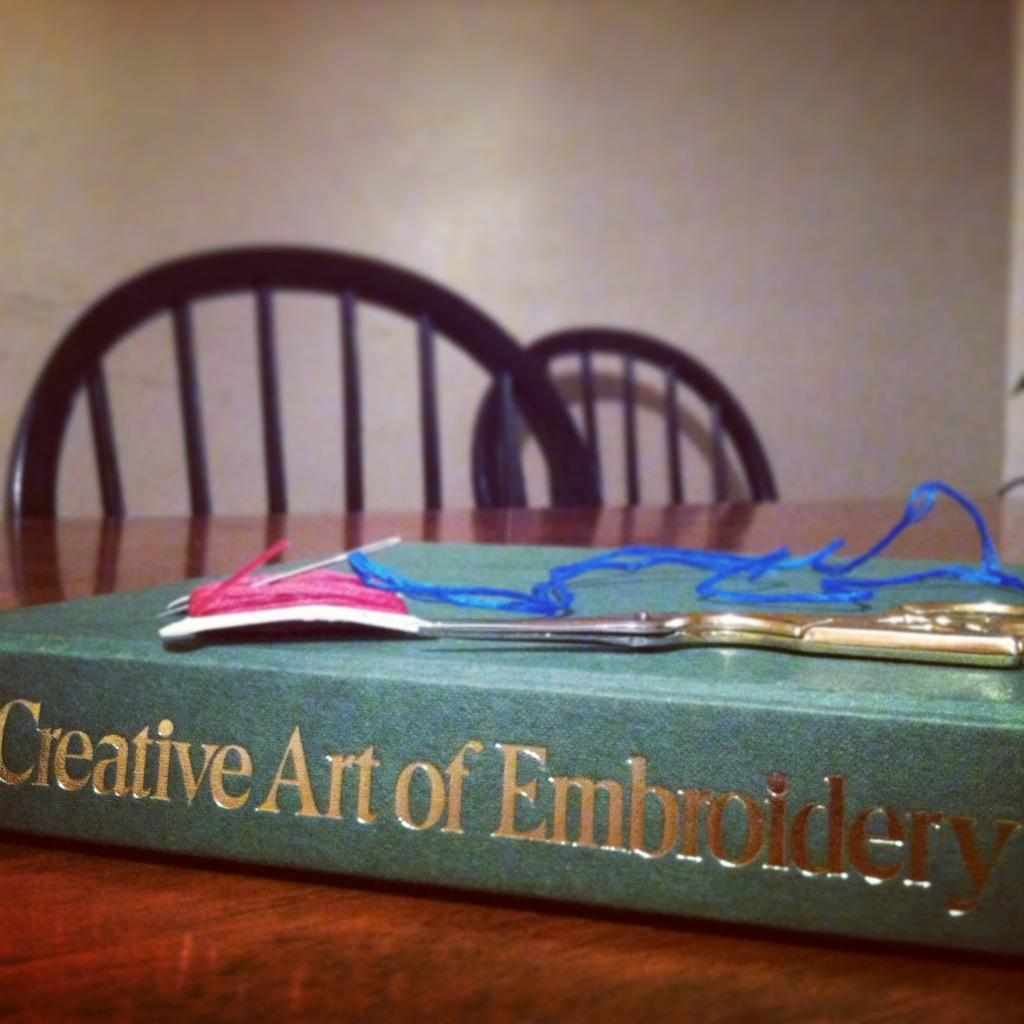<image>
Render a clear and concise summary of the photo. A book entitled "Creative Art of Embroidery" lays on its side on the table, with some scissors and thread on top of it. 